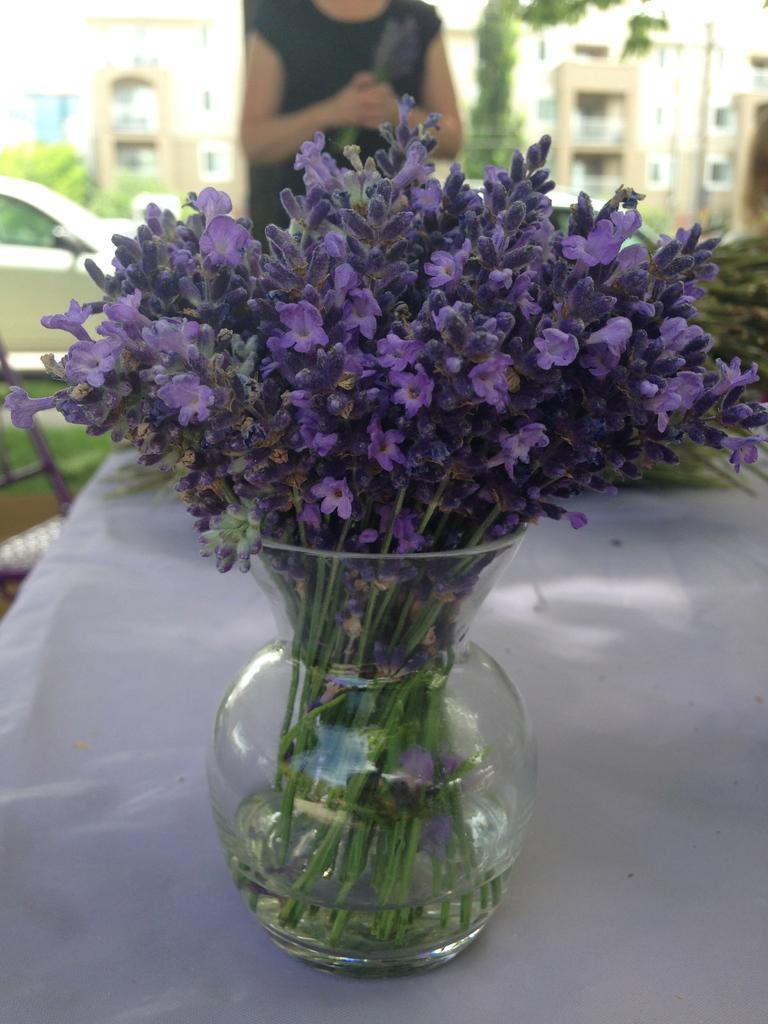Could you give a brief overview of what you see in this image? In this picture, we see a flower vase is placed on the white table. Behind that, we see a woman in black dress is stunning. On the left side, we see a car. There are trees and buildings in the background. 